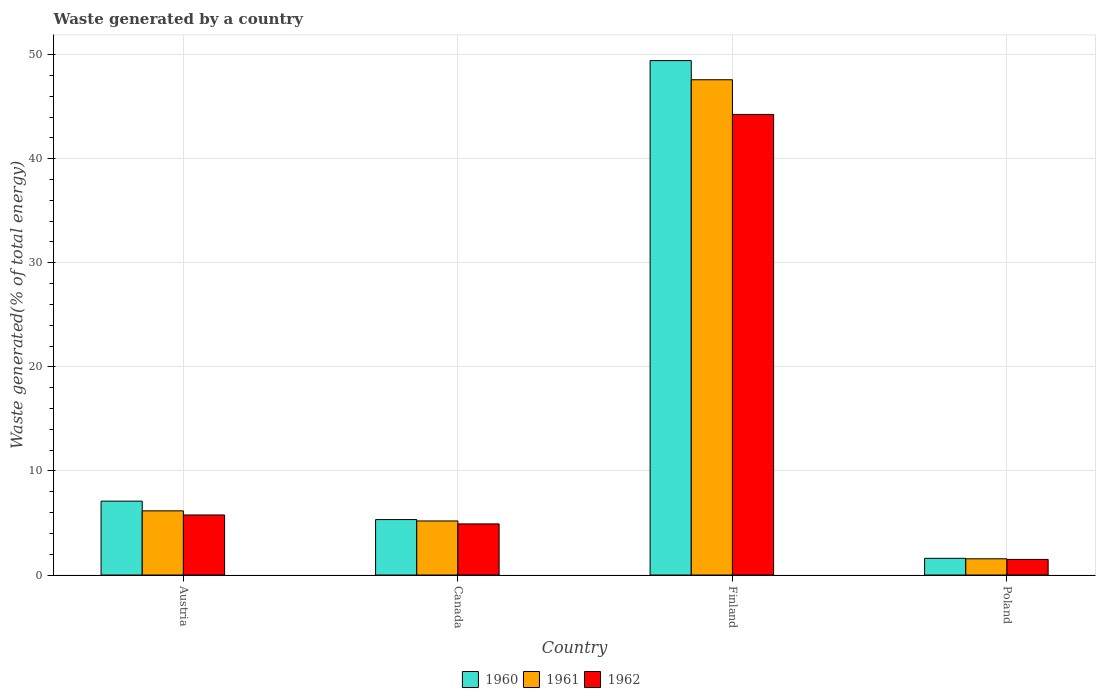Are the number of bars per tick equal to the number of legend labels?
Offer a very short reply. Yes. Are the number of bars on each tick of the X-axis equal?
Your answer should be very brief. Yes. What is the total waste generated in 1961 in Finland?
Provide a short and direct response. 47.58. Across all countries, what is the maximum total waste generated in 1961?
Your answer should be very brief. 47.58. Across all countries, what is the minimum total waste generated in 1962?
Make the answer very short. 1.5. In which country was the total waste generated in 1960 minimum?
Your answer should be very brief. Poland. What is the total total waste generated in 1960 in the graph?
Give a very brief answer. 63.45. What is the difference between the total waste generated in 1962 in Austria and that in Poland?
Ensure brevity in your answer.  4.27. What is the difference between the total waste generated in 1962 in Canada and the total waste generated in 1960 in Finland?
Your response must be concise. -44.51. What is the average total waste generated in 1960 per country?
Your answer should be very brief. 15.86. What is the difference between the total waste generated of/in 1961 and total waste generated of/in 1960 in Canada?
Provide a short and direct response. -0.13. In how many countries, is the total waste generated in 1960 greater than 14 %?
Ensure brevity in your answer.  1. What is the ratio of the total waste generated in 1962 in Finland to that in Poland?
Offer a terse response. 29.52. Is the difference between the total waste generated in 1961 in Austria and Canada greater than the difference between the total waste generated in 1960 in Austria and Canada?
Offer a very short reply. No. What is the difference between the highest and the second highest total waste generated in 1961?
Keep it short and to the point. -0.97. What is the difference between the highest and the lowest total waste generated in 1960?
Your response must be concise. 47.82. In how many countries, is the total waste generated in 1961 greater than the average total waste generated in 1961 taken over all countries?
Give a very brief answer. 1. What does the 2nd bar from the left in Canada represents?
Give a very brief answer. 1961. What does the 3rd bar from the right in Canada represents?
Provide a succinct answer. 1960. How many countries are there in the graph?
Offer a terse response. 4. What is the difference between two consecutive major ticks on the Y-axis?
Offer a very short reply. 10. Are the values on the major ticks of Y-axis written in scientific E-notation?
Provide a short and direct response. No. Where does the legend appear in the graph?
Provide a succinct answer. Bottom center. How many legend labels are there?
Offer a terse response. 3. What is the title of the graph?
Your answer should be very brief. Waste generated by a country. Does "1963" appear as one of the legend labels in the graph?
Ensure brevity in your answer.  No. What is the label or title of the X-axis?
Offer a terse response. Country. What is the label or title of the Y-axis?
Your answer should be compact. Waste generated(% of total energy). What is the Waste generated(% of total energy) in 1960 in Austria?
Your answer should be very brief. 7.1. What is the Waste generated(% of total energy) of 1961 in Austria?
Your answer should be very brief. 6.16. What is the Waste generated(% of total energy) in 1962 in Austria?
Your answer should be very brief. 5.77. What is the Waste generated(% of total energy) in 1960 in Canada?
Your response must be concise. 5.33. What is the Waste generated(% of total energy) of 1961 in Canada?
Your answer should be compact. 5.19. What is the Waste generated(% of total energy) in 1962 in Canada?
Offer a very short reply. 4.91. What is the Waste generated(% of total energy) of 1960 in Finland?
Your response must be concise. 49.42. What is the Waste generated(% of total energy) in 1961 in Finland?
Keep it short and to the point. 47.58. What is the Waste generated(% of total energy) in 1962 in Finland?
Ensure brevity in your answer.  44.25. What is the Waste generated(% of total energy) of 1960 in Poland?
Make the answer very short. 1.6. What is the Waste generated(% of total energy) in 1961 in Poland?
Ensure brevity in your answer.  1.56. What is the Waste generated(% of total energy) in 1962 in Poland?
Your answer should be compact. 1.5. Across all countries, what is the maximum Waste generated(% of total energy) in 1960?
Give a very brief answer. 49.42. Across all countries, what is the maximum Waste generated(% of total energy) in 1961?
Your answer should be very brief. 47.58. Across all countries, what is the maximum Waste generated(% of total energy) in 1962?
Keep it short and to the point. 44.25. Across all countries, what is the minimum Waste generated(% of total energy) of 1960?
Ensure brevity in your answer.  1.6. Across all countries, what is the minimum Waste generated(% of total energy) of 1961?
Your answer should be very brief. 1.56. Across all countries, what is the minimum Waste generated(% of total energy) of 1962?
Offer a very short reply. 1.5. What is the total Waste generated(% of total energy) of 1960 in the graph?
Your answer should be very brief. 63.45. What is the total Waste generated(% of total energy) in 1961 in the graph?
Make the answer very short. 60.5. What is the total Waste generated(% of total energy) of 1962 in the graph?
Keep it short and to the point. 56.43. What is the difference between the Waste generated(% of total energy) in 1960 in Austria and that in Canada?
Give a very brief answer. 1.77. What is the difference between the Waste generated(% of total energy) in 1961 in Austria and that in Canada?
Offer a terse response. 0.97. What is the difference between the Waste generated(% of total energy) in 1962 in Austria and that in Canada?
Provide a short and direct response. 0.86. What is the difference between the Waste generated(% of total energy) of 1960 in Austria and that in Finland?
Give a very brief answer. -42.33. What is the difference between the Waste generated(% of total energy) in 1961 in Austria and that in Finland?
Your answer should be compact. -41.42. What is the difference between the Waste generated(% of total energy) in 1962 in Austria and that in Finland?
Your answer should be very brief. -38.48. What is the difference between the Waste generated(% of total energy) in 1960 in Austria and that in Poland?
Your response must be concise. 5.49. What is the difference between the Waste generated(% of total energy) in 1961 in Austria and that in Poland?
Provide a succinct answer. 4.61. What is the difference between the Waste generated(% of total energy) of 1962 in Austria and that in Poland?
Keep it short and to the point. 4.27. What is the difference between the Waste generated(% of total energy) in 1960 in Canada and that in Finland?
Your answer should be compact. -44.1. What is the difference between the Waste generated(% of total energy) in 1961 in Canada and that in Finland?
Give a very brief answer. -42.39. What is the difference between the Waste generated(% of total energy) of 1962 in Canada and that in Finland?
Make the answer very short. -39.34. What is the difference between the Waste generated(% of total energy) of 1960 in Canada and that in Poland?
Your answer should be compact. 3.72. What is the difference between the Waste generated(% of total energy) of 1961 in Canada and that in Poland?
Offer a terse response. 3.64. What is the difference between the Waste generated(% of total energy) in 1962 in Canada and that in Poland?
Keep it short and to the point. 3.41. What is the difference between the Waste generated(% of total energy) in 1960 in Finland and that in Poland?
Your response must be concise. 47.82. What is the difference between the Waste generated(% of total energy) in 1961 in Finland and that in Poland?
Give a very brief answer. 46.02. What is the difference between the Waste generated(% of total energy) of 1962 in Finland and that in Poland?
Your response must be concise. 42.75. What is the difference between the Waste generated(% of total energy) of 1960 in Austria and the Waste generated(% of total energy) of 1961 in Canada?
Offer a terse response. 1.9. What is the difference between the Waste generated(% of total energy) in 1960 in Austria and the Waste generated(% of total energy) in 1962 in Canada?
Offer a terse response. 2.19. What is the difference between the Waste generated(% of total energy) of 1961 in Austria and the Waste generated(% of total energy) of 1962 in Canada?
Ensure brevity in your answer.  1.25. What is the difference between the Waste generated(% of total energy) of 1960 in Austria and the Waste generated(% of total energy) of 1961 in Finland?
Give a very brief answer. -40.48. What is the difference between the Waste generated(% of total energy) of 1960 in Austria and the Waste generated(% of total energy) of 1962 in Finland?
Make the answer very short. -37.15. What is the difference between the Waste generated(% of total energy) of 1961 in Austria and the Waste generated(% of total energy) of 1962 in Finland?
Give a very brief answer. -38.09. What is the difference between the Waste generated(% of total energy) of 1960 in Austria and the Waste generated(% of total energy) of 1961 in Poland?
Ensure brevity in your answer.  5.54. What is the difference between the Waste generated(% of total energy) in 1960 in Austria and the Waste generated(% of total energy) in 1962 in Poland?
Offer a very short reply. 5.6. What is the difference between the Waste generated(% of total energy) of 1961 in Austria and the Waste generated(% of total energy) of 1962 in Poland?
Offer a terse response. 4.67. What is the difference between the Waste generated(% of total energy) in 1960 in Canada and the Waste generated(% of total energy) in 1961 in Finland?
Your response must be concise. -42.25. What is the difference between the Waste generated(% of total energy) of 1960 in Canada and the Waste generated(% of total energy) of 1962 in Finland?
Provide a short and direct response. -38.92. What is the difference between the Waste generated(% of total energy) in 1961 in Canada and the Waste generated(% of total energy) in 1962 in Finland?
Ensure brevity in your answer.  -39.06. What is the difference between the Waste generated(% of total energy) in 1960 in Canada and the Waste generated(% of total energy) in 1961 in Poland?
Keep it short and to the point. 3.77. What is the difference between the Waste generated(% of total energy) of 1960 in Canada and the Waste generated(% of total energy) of 1962 in Poland?
Offer a terse response. 3.83. What is the difference between the Waste generated(% of total energy) in 1961 in Canada and the Waste generated(% of total energy) in 1962 in Poland?
Provide a short and direct response. 3.7. What is the difference between the Waste generated(% of total energy) in 1960 in Finland and the Waste generated(% of total energy) in 1961 in Poland?
Offer a very short reply. 47.86. What is the difference between the Waste generated(% of total energy) in 1960 in Finland and the Waste generated(% of total energy) in 1962 in Poland?
Keep it short and to the point. 47.92. What is the difference between the Waste generated(% of total energy) of 1961 in Finland and the Waste generated(% of total energy) of 1962 in Poland?
Keep it short and to the point. 46.08. What is the average Waste generated(% of total energy) of 1960 per country?
Keep it short and to the point. 15.86. What is the average Waste generated(% of total energy) of 1961 per country?
Offer a terse response. 15.12. What is the average Waste generated(% of total energy) of 1962 per country?
Give a very brief answer. 14.11. What is the difference between the Waste generated(% of total energy) of 1960 and Waste generated(% of total energy) of 1961 in Austria?
Provide a short and direct response. 0.93. What is the difference between the Waste generated(% of total energy) of 1960 and Waste generated(% of total energy) of 1962 in Austria?
Give a very brief answer. 1.33. What is the difference between the Waste generated(% of total energy) in 1961 and Waste generated(% of total energy) in 1962 in Austria?
Your response must be concise. 0.4. What is the difference between the Waste generated(% of total energy) of 1960 and Waste generated(% of total energy) of 1961 in Canada?
Keep it short and to the point. 0.13. What is the difference between the Waste generated(% of total energy) in 1960 and Waste generated(% of total energy) in 1962 in Canada?
Your answer should be very brief. 0.42. What is the difference between the Waste generated(% of total energy) in 1961 and Waste generated(% of total energy) in 1962 in Canada?
Keep it short and to the point. 0.28. What is the difference between the Waste generated(% of total energy) of 1960 and Waste generated(% of total energy) of 1961 in Finland?
Provide a short and direct response. 1.84. What is the difference between the Waste generated(% of total energy) in 1960 and Waste generated(% of total energy) in 1962 in Finland?
Provide a succinct answer. 5.17. What is the difference between the Waste generated(% of total energy) in 1961 and Waste generated(% of total energy) in 1962 in Finland?
Provide a succinct answer. 3.33. What is the difference between the Waste generated(% of total energy) in 1960 and Waste generated(% of total energy) in 1961 in Poland?
Provide a short and direct response. 0.05. What is the difference between the Waste generated(% of total energy) in 1960 and Waste generated(% of total energy) in 1962 in Poland?
Offer a terse response. 0.11. What is the difference between the Waste generated(% of total energy) of 1961 and Waste generated(% of total energy) of 1962 in Poland?
Your answer should be very brief. 0.06. What is the ratio of the Waste generated(% of total energy) in 1960 in Austria to that in Canada?
Provide a short and direct response. 1.33. What is the ratio of the Waste generated(% of total energy) in 1961 in Austria to that in Canada?
Offer a terse response. 1.19. What is the ratio of the Waste generated(% of total energy) of 1962 in Austria to that in Canada?
Your answer should be very brief. 1.17. What is the ratio of the Waste generated(% of total energy) in 1960 in Austria to that in Finland?
Provide a succinct answer. 0.14. What is the ratio of the Waste generated(% of total energy) in 1961 in Austria to that in Finland?
Provide a short and direct response. 0.13. What is the ratio of the Waste generated(% of total energy) of 1962 in Austria to that in Finland?
Provide a short and direct response. 0.13. What is the ratio of the Waste generated(% of total energy) in 1960 in Austria to that in Poland?
Provide a short and direct response. 4.42. What is the ratio of the Waste generated(% of total energy) in 1961 in Austria to that in Poland?
Your answer should be very brief. 3.96. What is the ratio of the Waste generated(% of total energy) of 1962 in Austria to that in Poland?
Provide a short and direct response. 3.85. What is the ratio of the Waste generated(% of total energy) of 1960 in Canada to that in Finland?
Provide a short and direct response. 0.11. What is the ratio of the Waste generated(% of total energy) in 1961 in Canada to that in Finland?
Provide a succinct answer. 0.11. What is the ratio of the Waste generated(% of total energy) of 1962 in Canada to that in Finland?
Offer a very short reply. 0.11. What is the ratio of the Waste generated(% of total energy) in 1960 in Canada to that in Poland?
Your answer should be compact. 3.32. What is the ratio of the Waste generated(% of total energy) of 1961 in Canada to that in Poland?
Make the answer very short. 3.33. What is the ratio of the Waste generated(% of total energy) in 1962 in Canada to that in Poland?
Keep it short and to the point. 3.28. What is the ratio of the Waste generated(% of total energy) of 1960 in Finland to that in Poland?
Your response must be concise. 30.8. What is the ratio of the Waste generated(% of total energy) of 1961 in Finland to that in Poland?
Provide a short and direct response. 30.53. What is the ratio of the Waste generated(% of total energy) of 1962 in Finland to that in Poland?
Provide a short and direct response. 29.52. What is the difference between the highest and the second highest Waste generated(% of total energy) in 1960?
Give a very brief answer. 42.33. What is the difference between the highest and the second highest Waste generated(% of total energy) in 1961?
Provide a short and direct response. 41.42. What is the difference between the highest and the second highest Waste generated(% of total energy) in 1962?
Offer a very short reply. 38.48. What is the difference between the highest and the lowest Waste generated(% of total energy) in 1960?
Give a very brief answer. 47.82. What is the difference between the highest and the lowest Waste generated(% of total energy) in 1961?
Keep it short and to the point. 46.02. What is the difference between the highest and the lowest Waste generated(% of total energy) in 1962?
Offer a terse response. 42.75. 